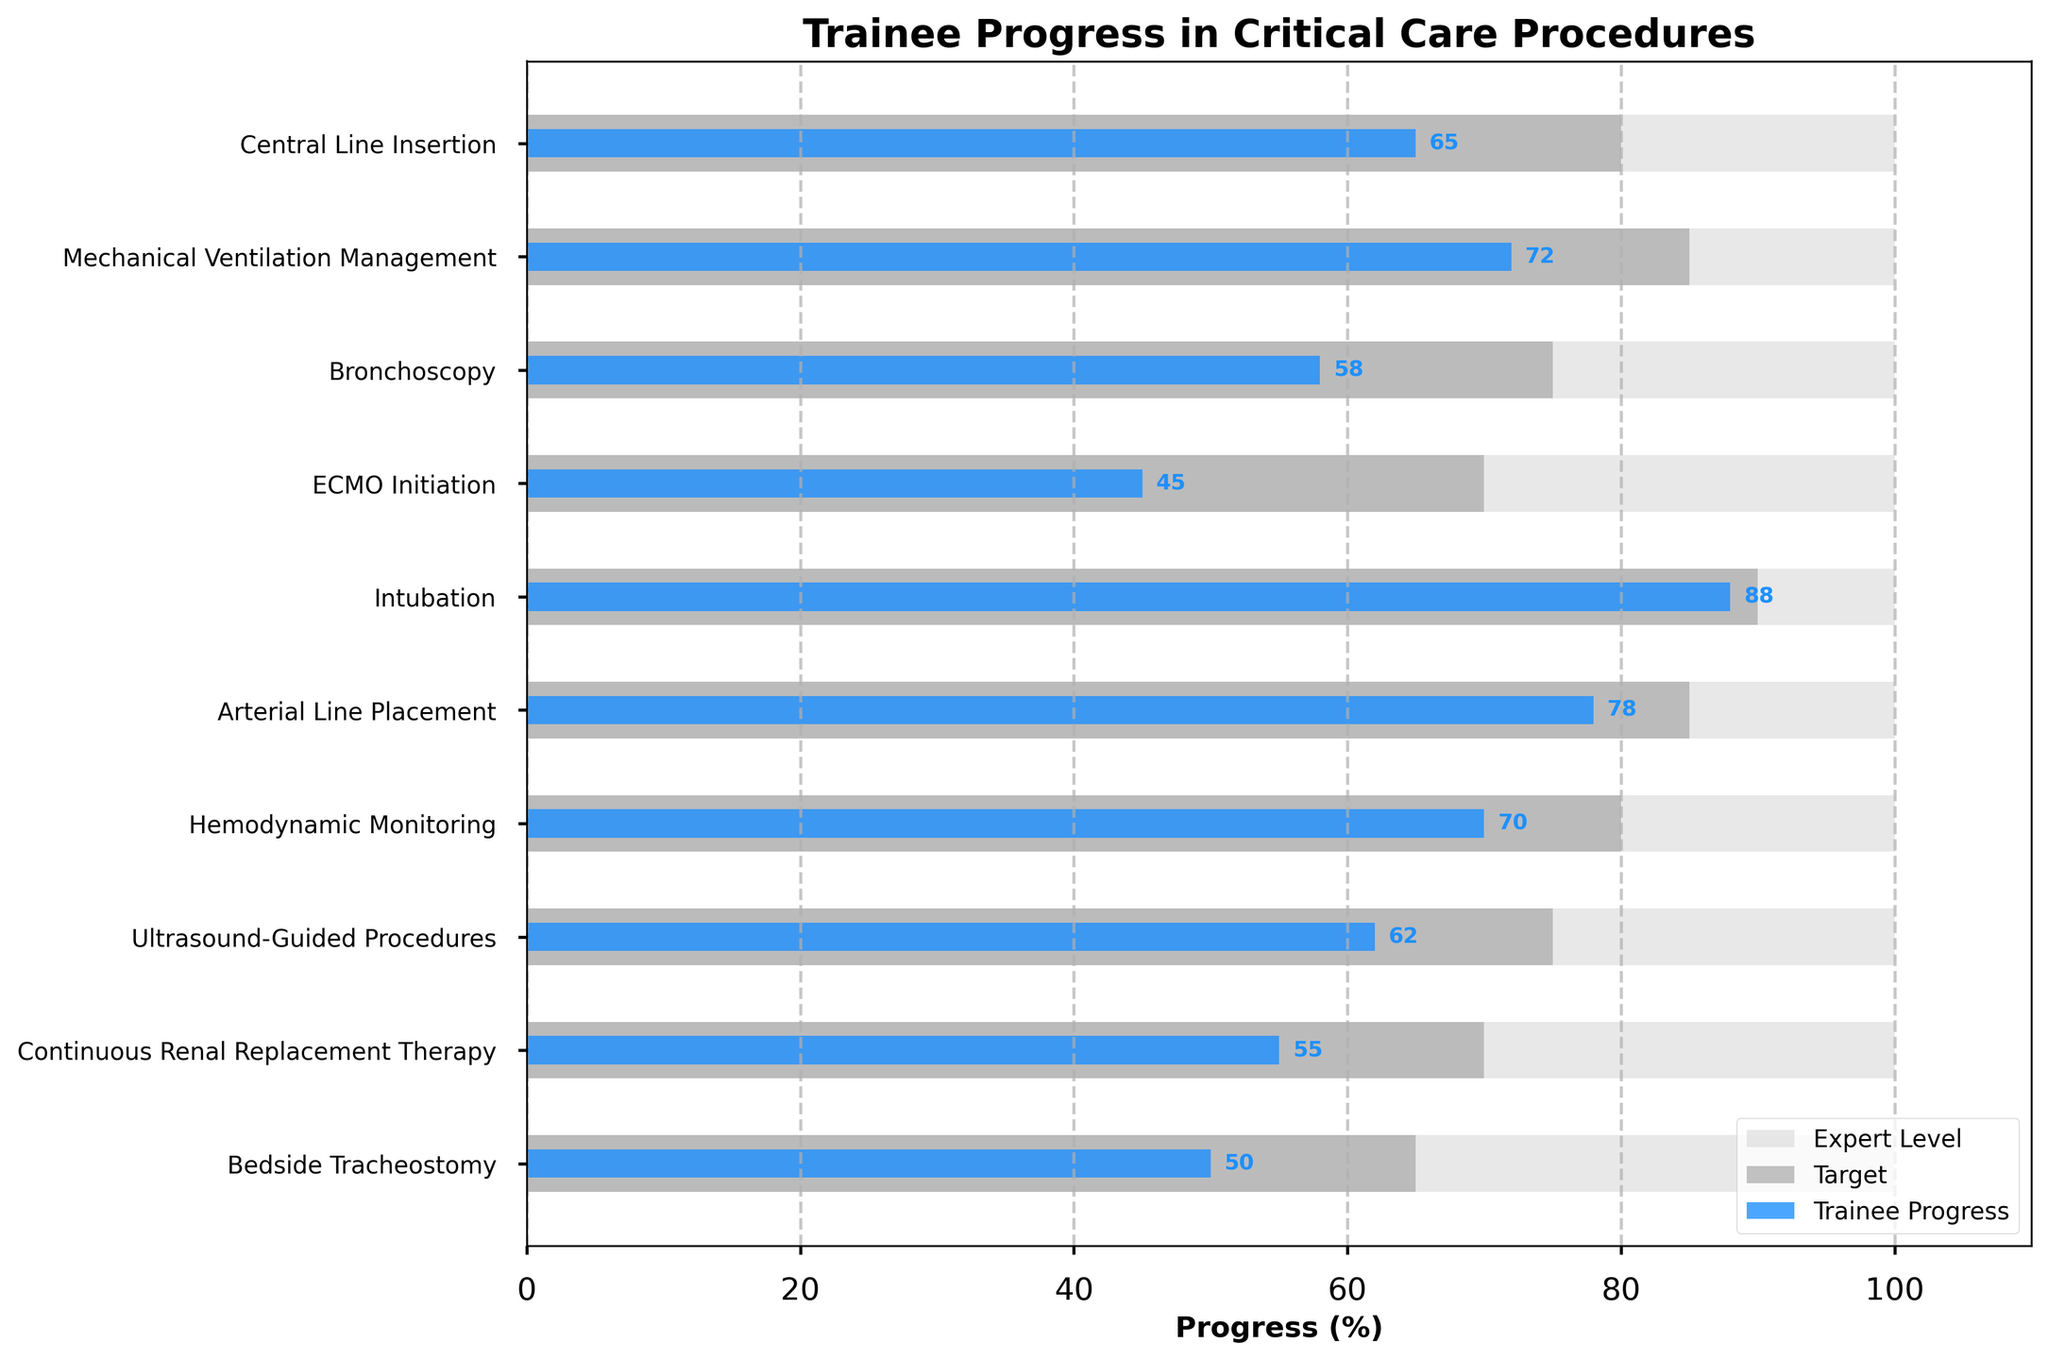What is the title of the plot? The title of the plot is the text located at the top of the figure. Here, you can see it reads "Trainee Progress in Critical Care Procedures".
Answer: Trainee Progress in Critical Care Procedures Which procedure has the highest trainee progress? To identify the procedure with the highest trainee progress, look for the longest blue bar. Here, "Intubation" has the longest blue bar at 88%.
Answer: Intubation What is the target progress for Mechanical Ventilation Management? Check for the label corresponding to "Mechanical Ventilation Management" and look at the dark grey bar's length. The target value shown is 85%.
Answer: 85% How does trainee progress in Bronchoscopy compare to the target? Look at the blue bar for "Bronchoscopy" and compare its length to the dark grey bar. The trainee progress is 58%, whereas the target is 75%, indicating a shortfall.
Answer: Trainee progress is 17% below the target Which procedures have trainee progress above 70%? Identify the blue bars that exceed the 70% mark. They are "Intubation" (88%), "Mechanical Ventilation Management" (72%), and "Arterial Line Placement" (78%).
Answer: Intubation, Mechanical Ventilation Management, Arterial Line Placement Which procedure has the largest gap between trainee progress and the expert level, and what is that gap? Find the procedure where the difference between the blue bar (trainee progress) and the light grey bar (expert level, always 100%) is the largest. For "ECMO Initiation," the gap is the largest: 100% - 45% = 55%.
Answer: ECMO Initiation, 55% What is the average target progress across all procedures? The target values are: 80, 85, 75, 70, 90, 85, 80, 75, 70, and 65. Sum them (775) and divide by the number of procedures (10): 775 / 10 = 77.5%.
Answer: 77.5% Which procedure shows the least progress made by trainees, and what is that value? Observe the shortest blue bar in the chart, corresponding to "ECMO Initiation" with a progress value of 45%.
Answer: ECMO Initiation, 45% What is the difference between the target and trainee progress for Continuous Renal Replacement Therapy? Compare the blue bar (trainee progress, 55%) with the dark grey bar (target, 70%) and subtract the trainee progress from the target: 70% - 55% = 15%.
Answer: 15% 